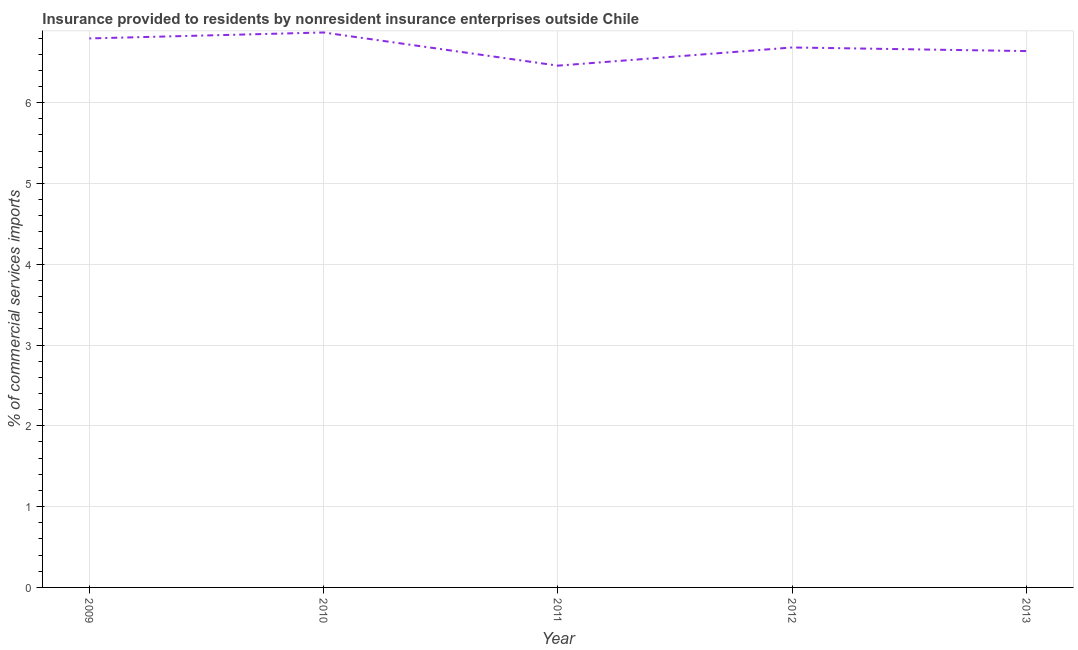What is the insurance provided by non-residents in 2009?
Your response must be concise. 6.8. Across all years, what is the maximum insurance provided by non-residents?
Your answer should be compact. 6.87. Across all years, what is the minimum insurance provided by non-residents?
Offer a very short reply. 6.46. In which year was the insurance provided by non-residents maximum?
Your response must be concise. 2010. In which year was the insurance provided by non-residents minimum?
Your response must be concise. 2011. What is the sum of the insurance provided by non-residents?
Offer a very short reply. 33.44. What is the difference between the insurance provided by non-residents in 2009 and 2010?
Your answer should be very brief. -0.07. What is the average insurance provided by non-residents per year?
Your response must be concise. 6.69. What is the median insurance provided by non-residents?
Give a very brief answer. 6.68. In how many years, is the insurance provided by non-residents greater than 6 %?
Provide a succinct answer. 5. Do a majority of the years between 2009 and 2012 (inclusive) have insurance provided by non-residents greater than 4 %?
Offer a terse response. Yes. What is the ratio of the insurance provided by non-residents in 2009 to that in 2011?
Make the answer very short. 1.05. Is the insurance provided by non-residents in 2009 less than that in 2011?
Offer a very short reply. No. What is the difference between the highest and the second highest insurance provided by non-residents?
Make the answer very short. 0.07. Is the sum of the insurance provided by non-residents in 2010 and 2013 greater than the maximum insurance provided by non-residents across all years?
Provide a succinct answer. Yes. What is the difference between the highest and the lowest insurance provided by non-residents?
Your answer should be compact. 0.41. Does the insurance provided by non-residents monotonically increase over the years?
Make the answer very short. No. What is the difference between two consecutive major ticks on the Y-axis?
Your answer should be compact. 1. What is the title of the graph?
Provide a short and direct response. Insurance provided to residents by nonresident insurance enterprises outside Chile. What is the label or title of the X-axis?
Provide a short and direct response. Year. What is the label or title of the Y-axis?
Your response must be concise. % of commercial services imports. What is the % of commercial services imports of 2009?
Provide a short and direct response. 6.8. What is the % of commercial services imports in 2010?
Make the answer very short. 6.87. What is the % of commercial services imports in 2011?
Make the answer very short. 6.46. What is the % of commercial services imports in 2012?
Provide a succinct answer. 6.68. What is the % of commercial services imports of 2013?
Your response must be concise. 6.64. What is the difference between the % of commercial services imports in 2009 and 2010?
Your answer should be compact. -0.07. What is the difference between the % of commercial services imports in 2009 and 2011?
Make the answer very short. 0.34. What is the difference between the % of commercial services imports in 2009 and 2012?
Your response must be concise. 0.11. What is the difference between the % of commercial services imports in 2009 and 2013?
Keep it short and to the point. 0.16. What is the difference between the % of commercial services imports in 2010 and 2011?
Offer a terse response. 0.41. What is the difference between the % of commercial services imports in 2010 and 2012?
Your answer should be compact. 0.19. What is the difference between the % of commercial services imports in 2010 and 2013?
Your answer should be compact. 0.23. What is the difference between the % of commercial services imports in 2011 and 2012?
Your response must be concise. -0.23. What is the difference between the % of commercial services imports in 2011 and 2013?
Your response must be concise. -0.18. What is the difference between the % of commercial services imports in 2012 and 2013?
Give a very brief answer. 0.04. What is the ratio of the % of commercial services imports in 2009 to that in 2010?
Offer a terse response. 0.99. What is the ratio of the % of commercial services imports in 2009 to that in 2011?
Your response must be concise. 1.05. What is the ratio of the % of commercial services imports in 2010 to that in 2011?
Your answer should be compact. 1.06. What is the ratio of the % of commercial services imports in 2010 to that in 2012?
Ensure brevity in your answer.  1.03. What is the ratio of the % of commercial services imports in 2010 to that in 2013?
Your response must be concise. 1.03. What is the ratio of the % of commercial services imports in 2011 to that in 2013?
Provide a short and direct response. 0.97. What is the ratio of the % of commercial services imports in 2012 to that in 2013?
Provide a succinct answer. 1.01. 